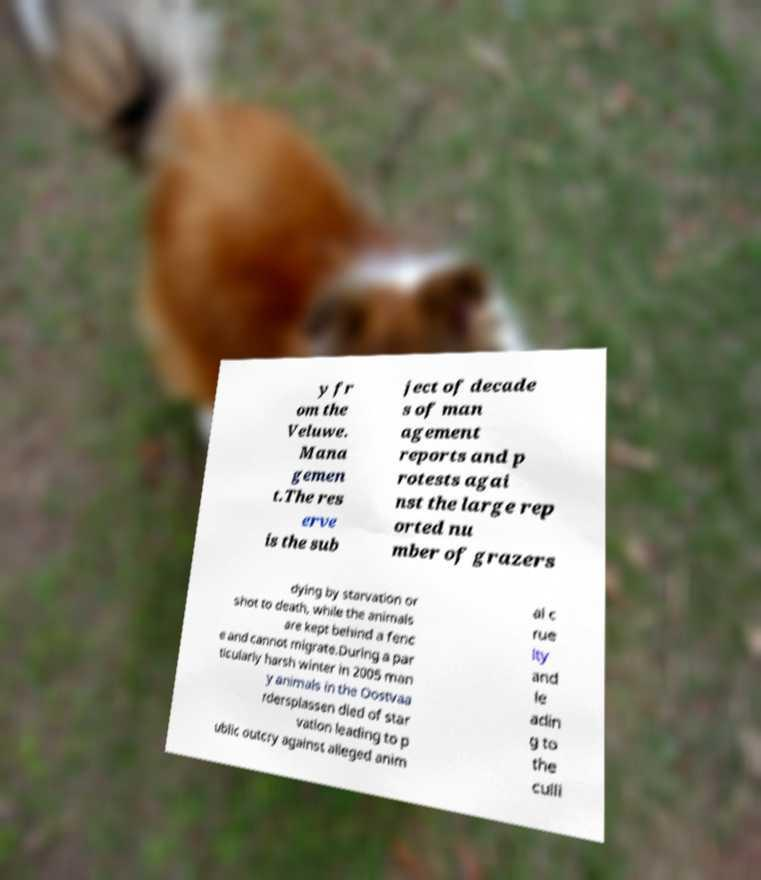What messages or text are displayed in this image? I need them in a readable, typed format. y fr om the Veluwe. Mana gemen t.The res erve is the sub ject of decade s of man agement reports and p rotests agai nst the large rep orted nu mber of grazers dying by starvation or shot to death, while the animals are kept behind a fenc e and cannot migrate.During a par ticularly harsh winter in 2005 man y animals in the Oostvaa rdersplassen died of star vation leading to p ublic outcry against alleged anim al c rue lty and le adin g to the culli 